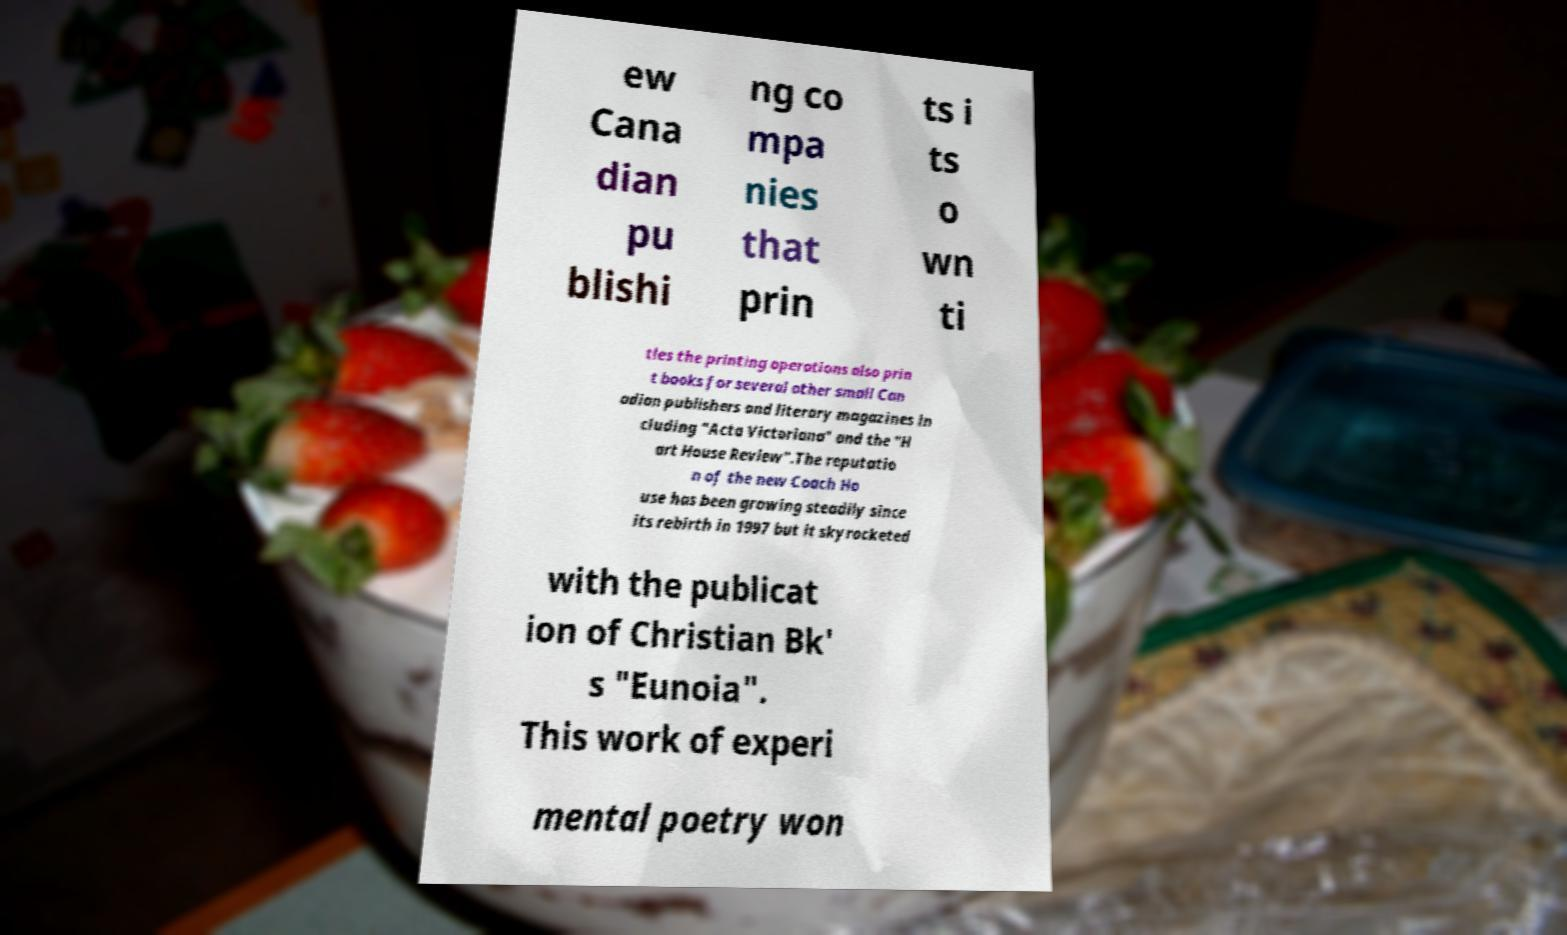Could you extract and type out the text from this image? ew Cana dian pu blishi ng co mpa nies that prin ts i ts o wn ti tles the printing operations also prin t books for several other small Can adian publishers and literary magazines in cluding "Acta Victoriana" and the "H art House Review".The reputatio n of the new Coach Ho use has been growing steadily since its rebirth in 1997 but it skyrocketed with the publicat ion of Christian Bk' s "Eunoia". This work of experi mental poetry won 